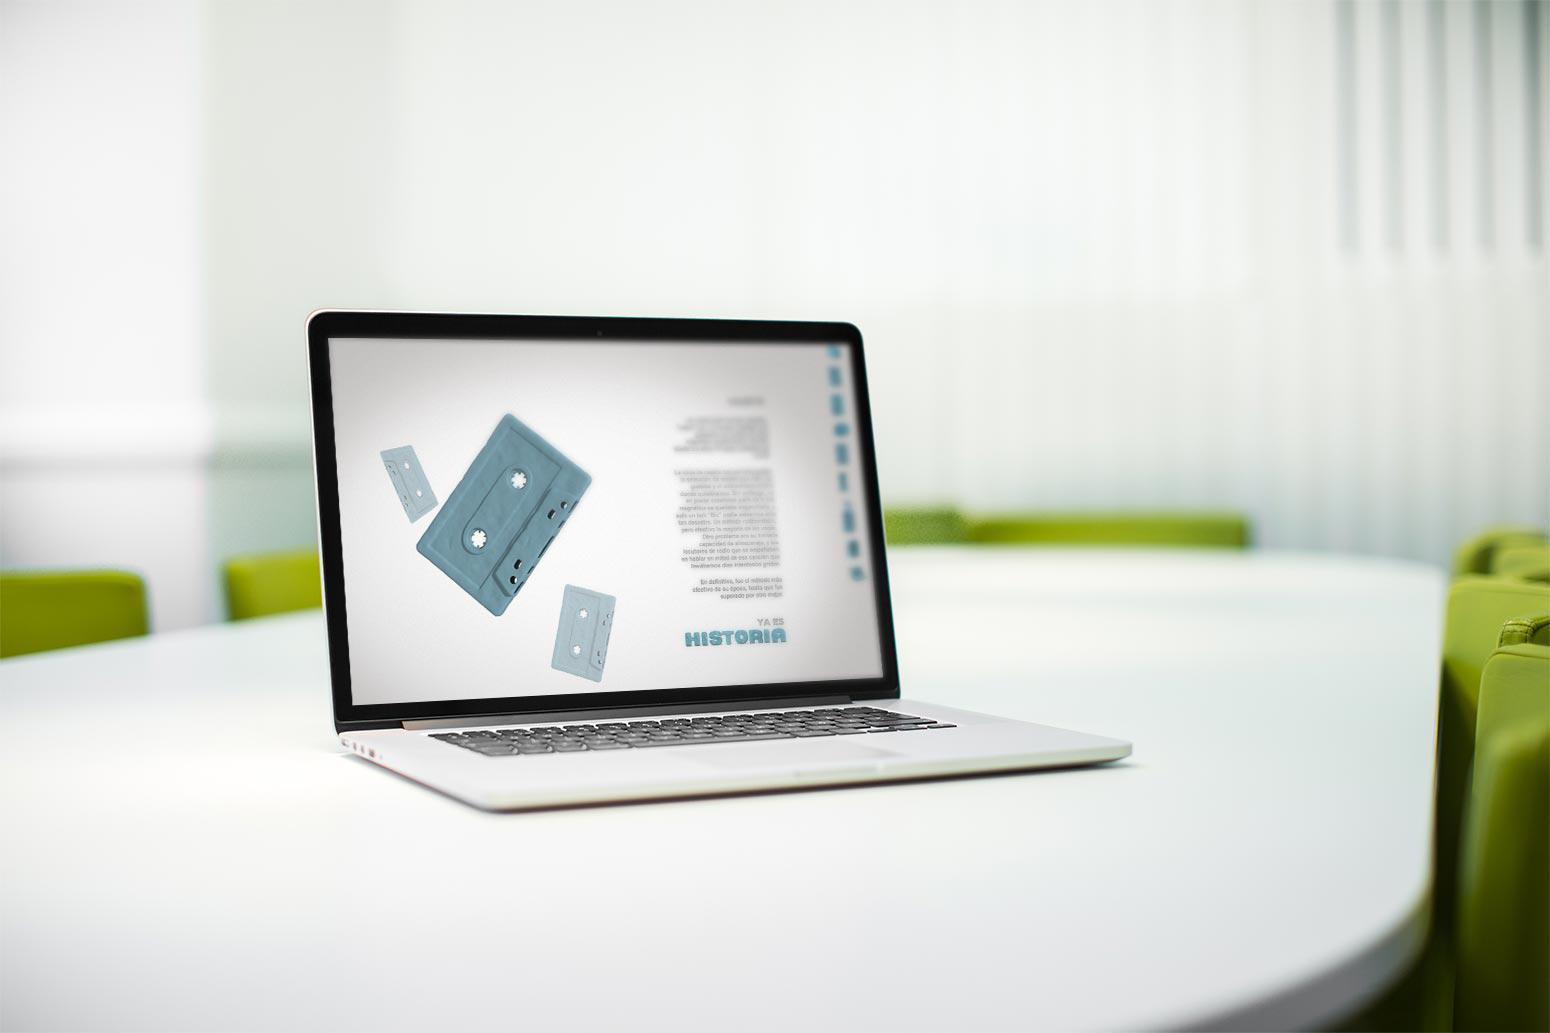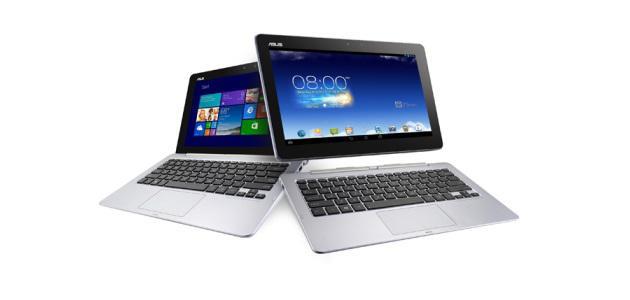The first image is the image on the left, the second image is the image on the right. Evaluate the accuracy of this statement regarding the images: "There are more devices in the image on the right.". Is it true? Answer yes or no. Yes. The first image is the image on the left, the second image is the image on the right. For the images shown, is this caption "The left image shows exactly one open forward-facing laptop on a white table, and the right image shows one open, forward-facing laptop overlapping another open, forward-facing laptop." true? Answer yes or no. Yes. 